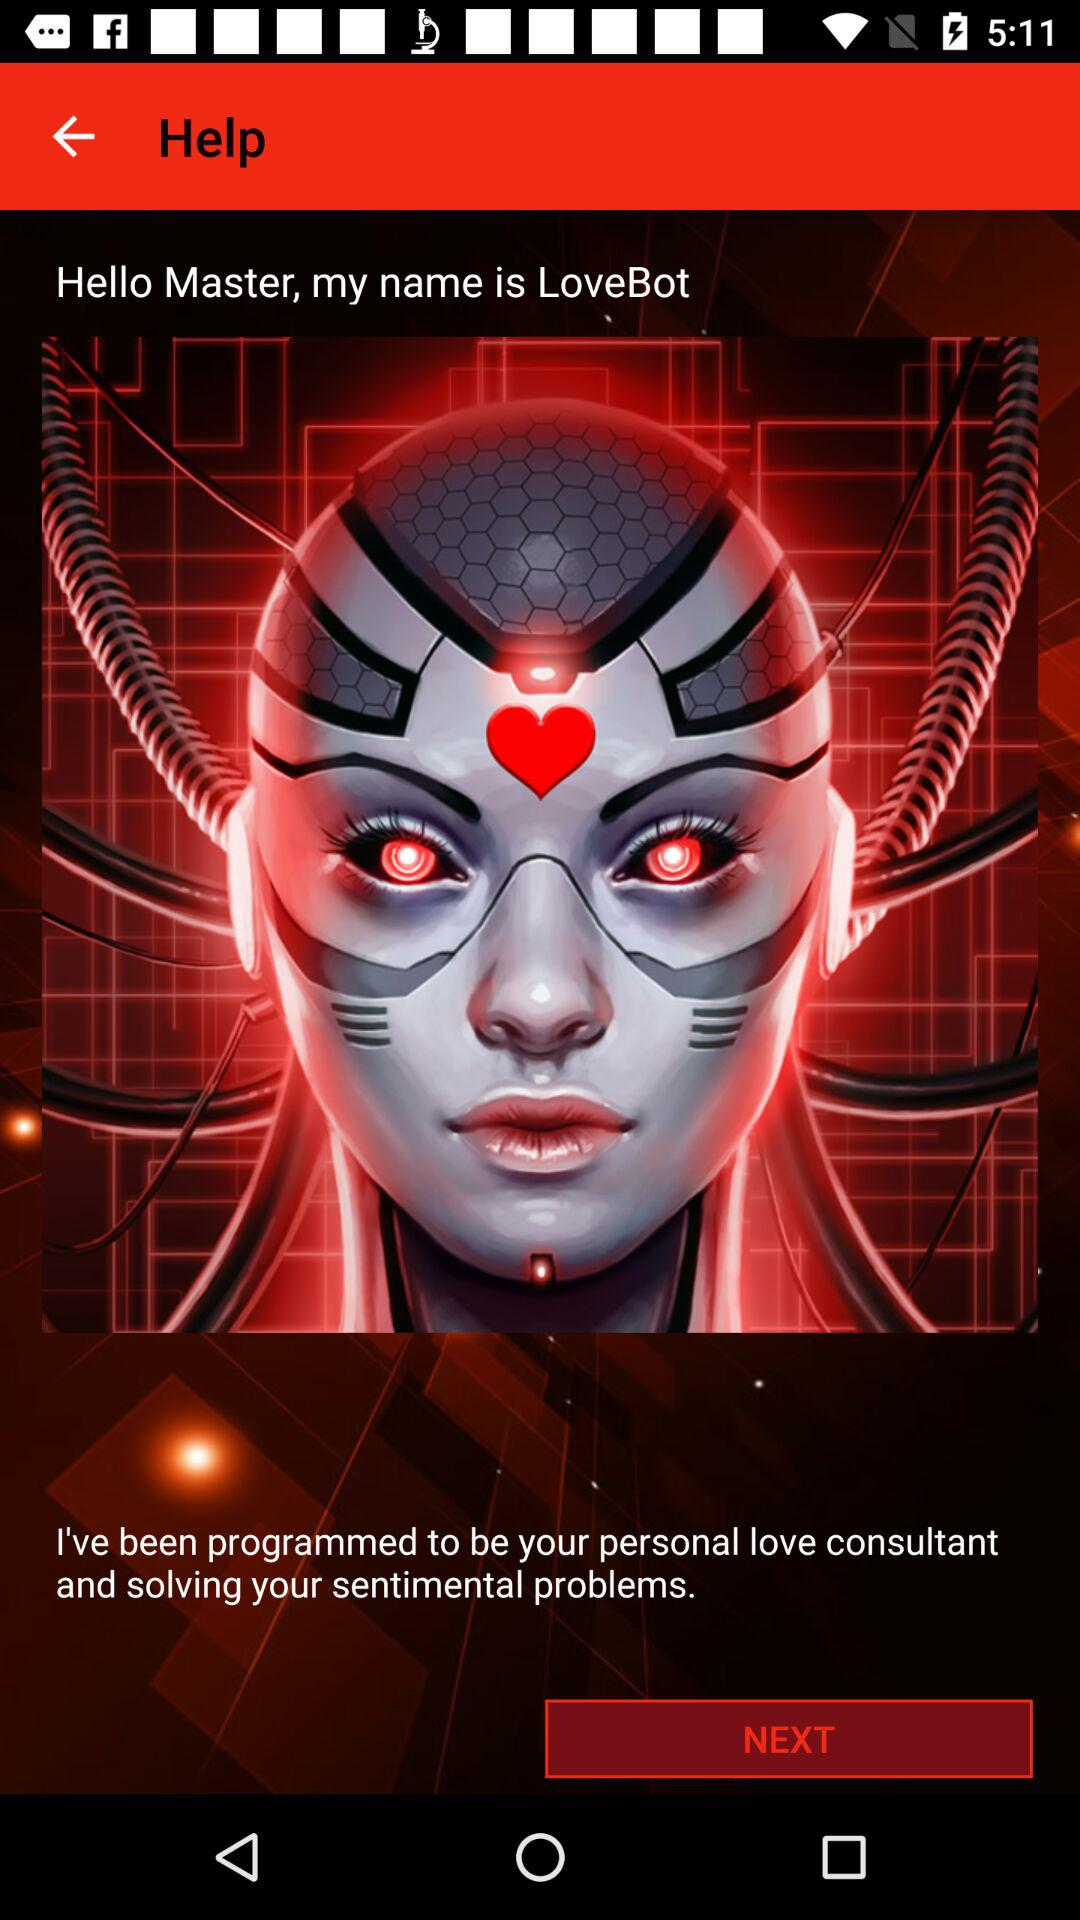Why has "LoveBot" been programmed? The "LoveBot" has been programmed to be your personal love consultant and solve your sentimental problems. 